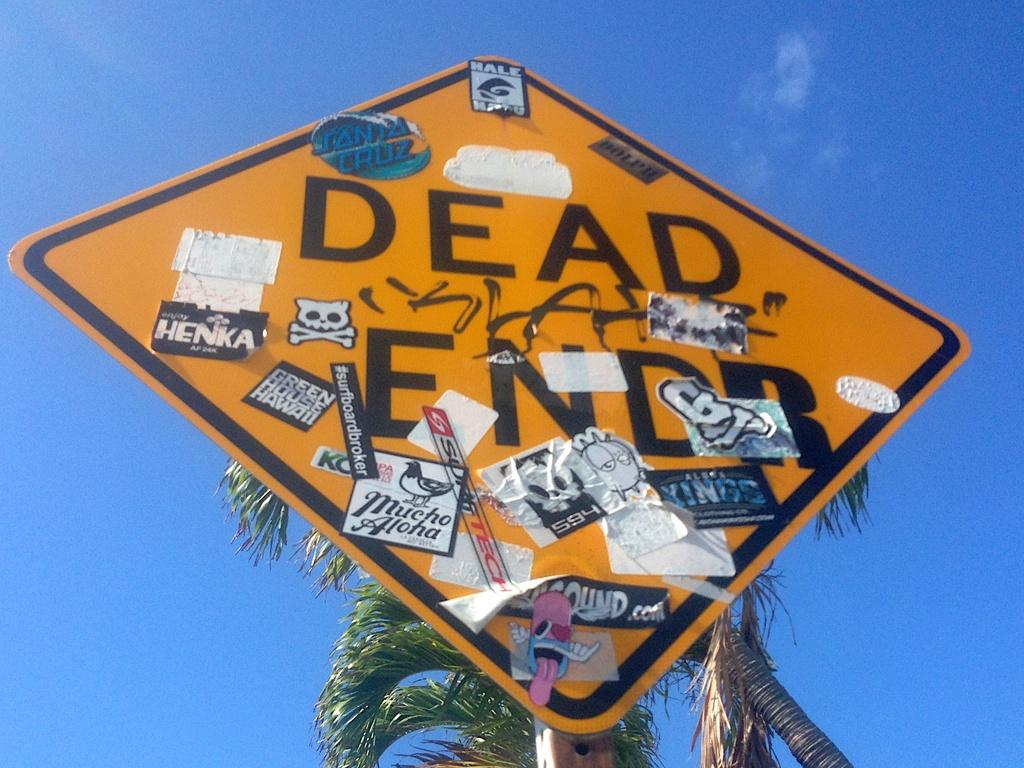What's the sign say?
Your answer should be compact. Dead end. 